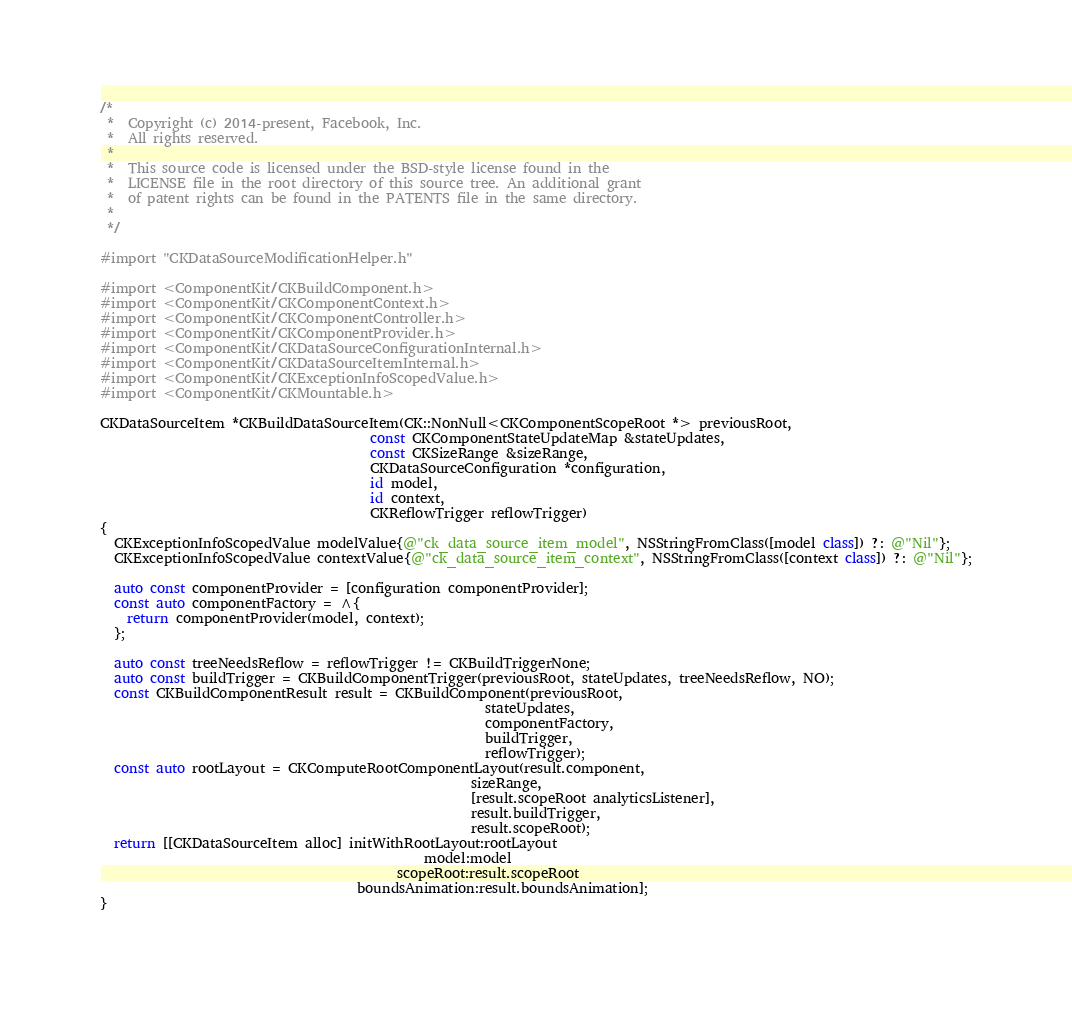<code> <loc_0><loc_0><loc_500><loc_500><_ObjectiveC_>/*
 *  Copyright (c) 2014-present, Facebook, Inc.
 *  All rights reserved.
 *
 *  This source code is licensed under the BSD-style license found in the
 *  LICENSE file in the root directory of this source tree. An additional grant
 *  of patent rights can be found in the PATENTS file in the same directory.
 *
 */

#import "CKDataSourceModificationHelper.h"

#import <ComponentKit/CKBuildComponent.h>
#import <ComponentKit/CKComponentContext.h>
#import <ComponentKit/CKComponentController.h>
#import <ComponentKit/CKComponentProvider.h>
#import <ComponentKit/CKDataSourceConfigurationInternal.h>
#import <ComponentKit/CKDataSourceItemInternal.h>
#import <ComponentKit/CKExceptionInfoScopedValue.h>
#import <ComponentKit/CKMountable.h>

CKDataSourceItem *CKBuildDataSourceItem(CK::NonNull<CKComponentScopeRoot *> previousRoot,
                                        const CKComponentStateUpdateMap &stateUpdates,
                                        const CKSizeRange &sizeRange,
                                        CKDataSourceConfiguration *configuration,
                                        id model,
                                        id context,
                                        CKReflowTrigger reflowTrigger)
{
  CKExceptionInfoScopedValue modelValue{@"ck_data_source_item_model", NSStringFromClass([model class]) ?: @"Nil"};
  CKExceptionInfoScopedValue contextValue{@"ck_data_source_item_context", NSStringFromClass([context class]) ?: @"Nil"};

  auto const componentProvider = [configuration componentProvider];
  const auto componentFactory = ^{
    return componentProvider(model, context);
  };

  auto const treeNeedsReflow = reflowTrigger != CKBuildTriggerNone;
  auto const buildTrigger = CKBuildComponentTrigger(previousRoot, stateUpdates, treeNeedsReflow, NO);
  const CKBuildComponentResult result = CKBuildComponent(previousRoot,
                                                         stateUpdates,
                                                         componentFactory,
                                                         buildTrigger,
                                                         reflowTrigger);
  const auto rootLayout = CKComputeRootComponentLayout(result.component,
                                                       sizeRange,
                                                       [result.scopeRoot analyticsListener],
                                                       result.buildTrigger,
                                                       result.scopeRoot);
  return [[CKDataSourceItem alloc] initWithRootLayout:rootLayout
                                                model:model
                                            scopeRoot:result.scopeRoot
                                      boundsAnimation:result.boundsAnimation];
}
</code> 